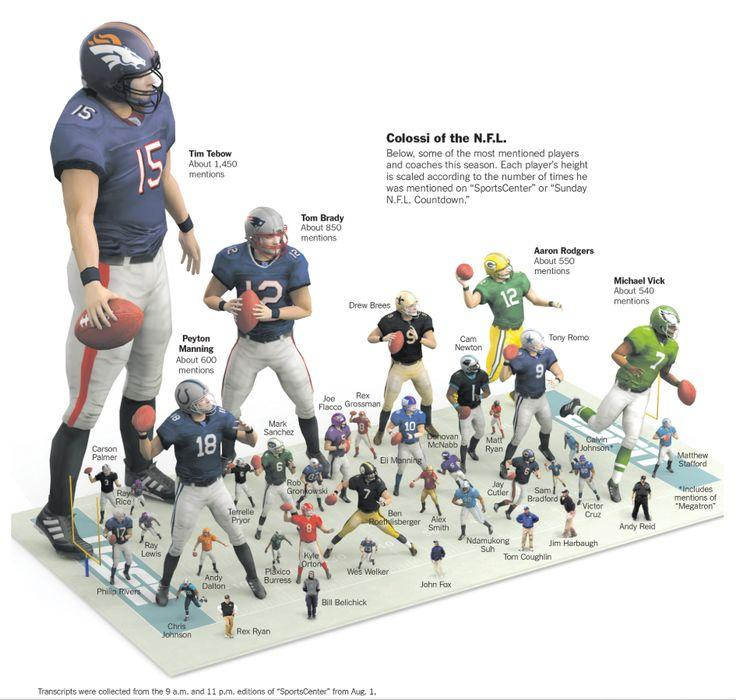Outline some significant characteristics in this image. Tom Brady received the second highest number of mentions on Sports Center Countdown, making him a notable player in the sports industry. There were 550 mentions of the player in Sports Center Countdown for Jersey Number 12. Peyton Manning was the player who received the third-highest number of mentions on Sports Center's Countdown, according to the information provided. The player in the green jersey with the number 7 is Michael Vick. 